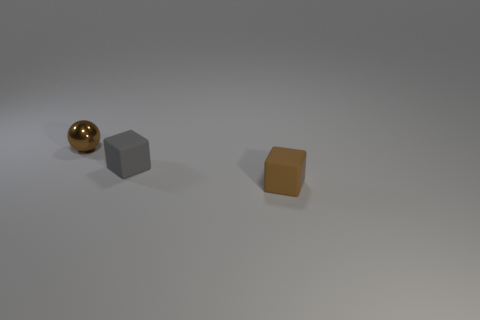What material is the other object that is the same color as the tiny metal thing?
Ensure brevity in your answer.  Rubber. There is a object that is right of the brown ball and behind the brown cube; what is its material?
Your response must be concise. Rubber. Does the tiny gray cube have the same material as the brown sphere?
Ensure brevity in your answer.  No. What number of other brown shiny things are the same size as the shiny thing?
Your response must be concise. 0. Is the number of brown matte things behind the tiny metallic ball the same as the number of small gray shiny things?
Your answer should be very brief. Yes. What number of things are behind the brown rubber object and on the right side of the small metallic thing?
Provide a short and direct response. 1. There is a small brown thing on the right side of the tiny brown metal sphere; is it the same shape as the gray object?
Provide a succinct answer. Yes. There is a ball that is the same size as the gray block; what material is it?
Your answer should be very brief. Metal. Are there an equal number of small cubes that are on the left side of the small brown shiny thing and small brown matte objects right of the tiny brown cube?
Keep it short and to the point. Yes. There is a small brown object that is behind the brown thing that is in front of the ball; what number of small blocks are left of it?
Your answer should be compact. 0. 